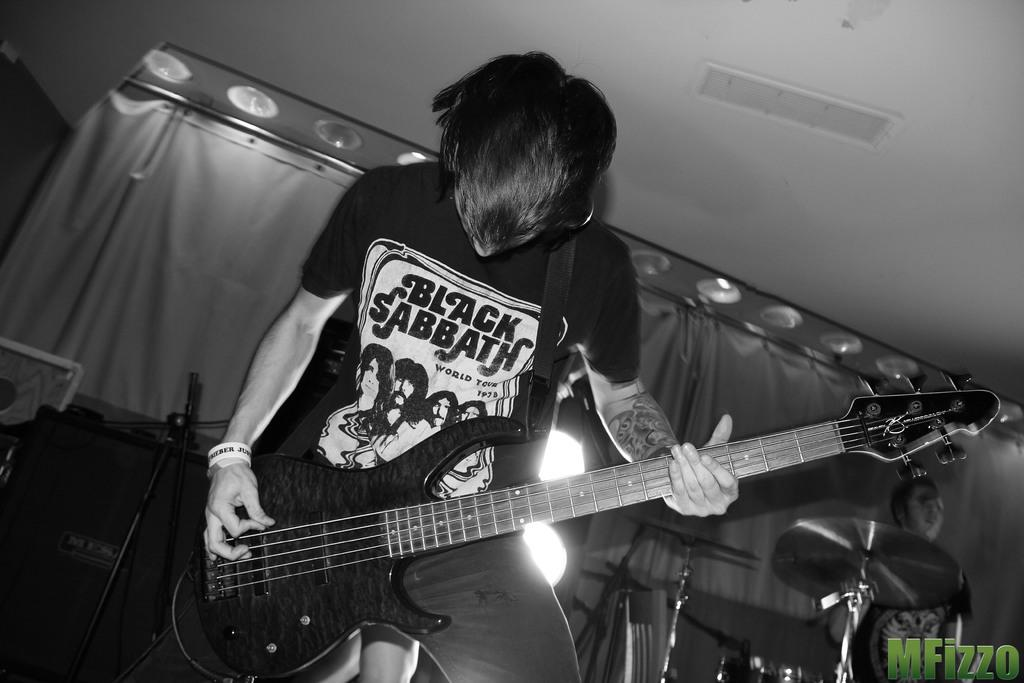What is the main subject of the image? There is a man in the image. What is the man doing in the image? The man is standing and playing the guitar. How is the man playing the guitar? The man is using his hands to play the guitar. What type of curtain can be seen hanging in the background of the image? There is no curtain visible in the image; it only features a man playing the guitar. 